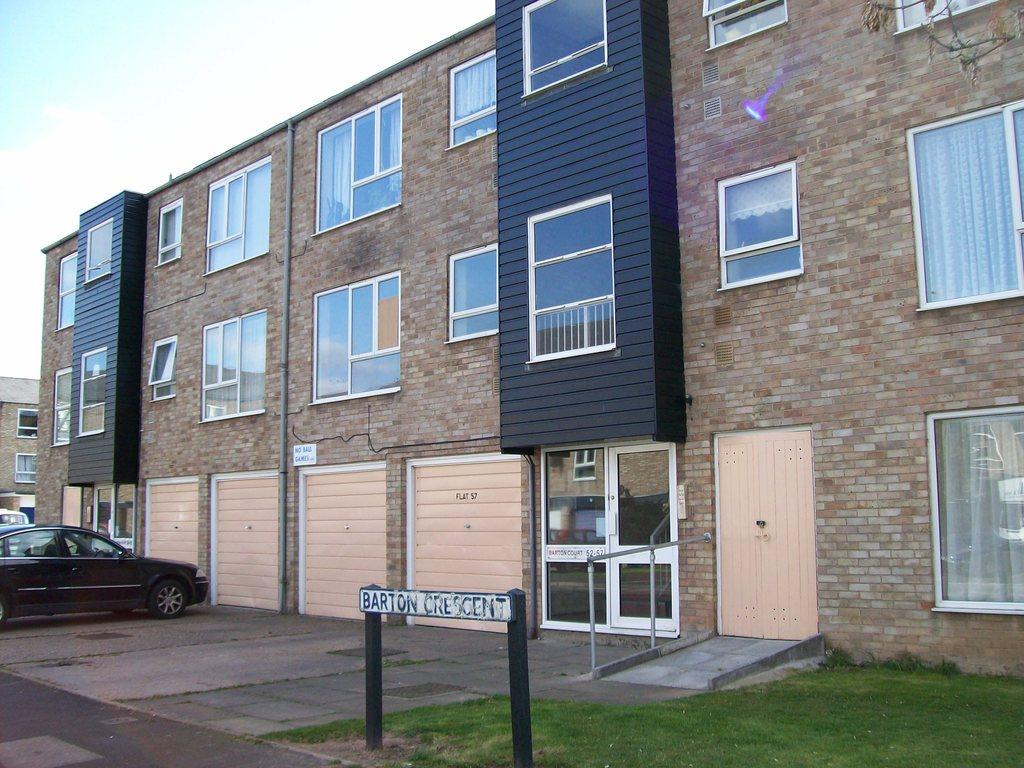What type of structure is present in the image? There is a building in the image. What features can be seen on the building? The building has windows and a door. What else can be seen in the image besides the building? There are cars, grass, and a road in the image. What is visible in the background of the image? The sky is visible in the background of the image. How many people are in the crowd gathered around the building in the image? There is no crowd present in the image; it only shows the building, cars, grass, and a road. What type of coat is the building wearing in the image? Buildings do not wear coats; the question is not applicable to the image. 